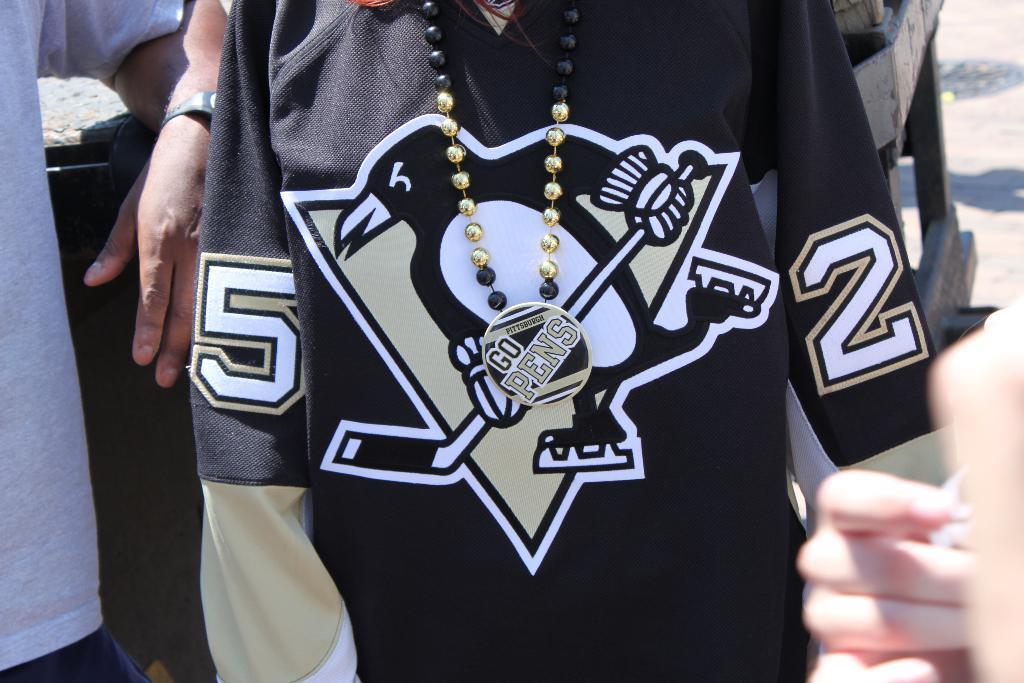What numbers on his jersey?
Provide a succinct answer. 52. What does the necklace say?
Your response must be concise. Go pens. 